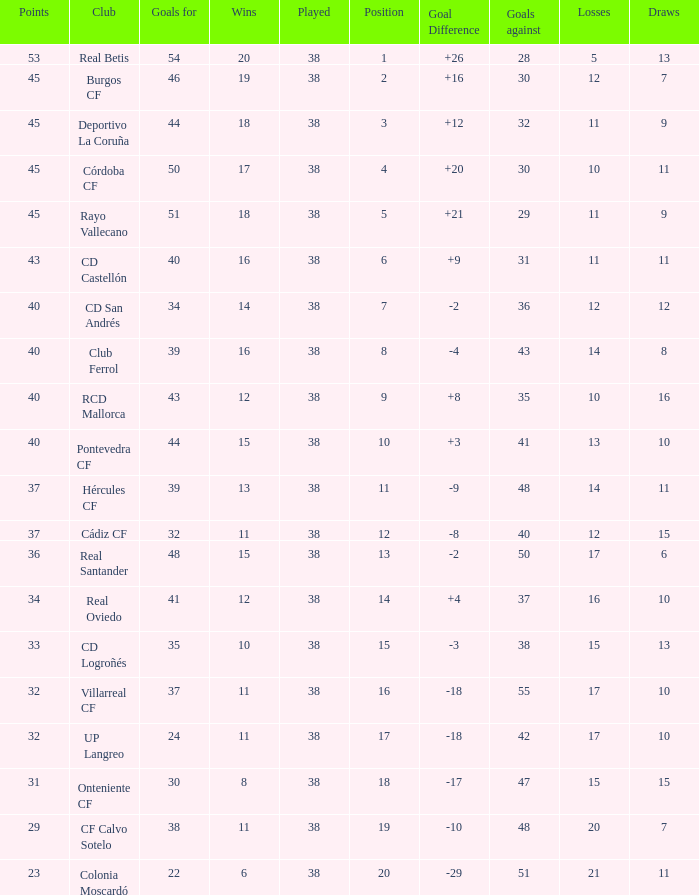What is the average Played, when Club is "Burgos CF", and when Draws is less than 7? None. 